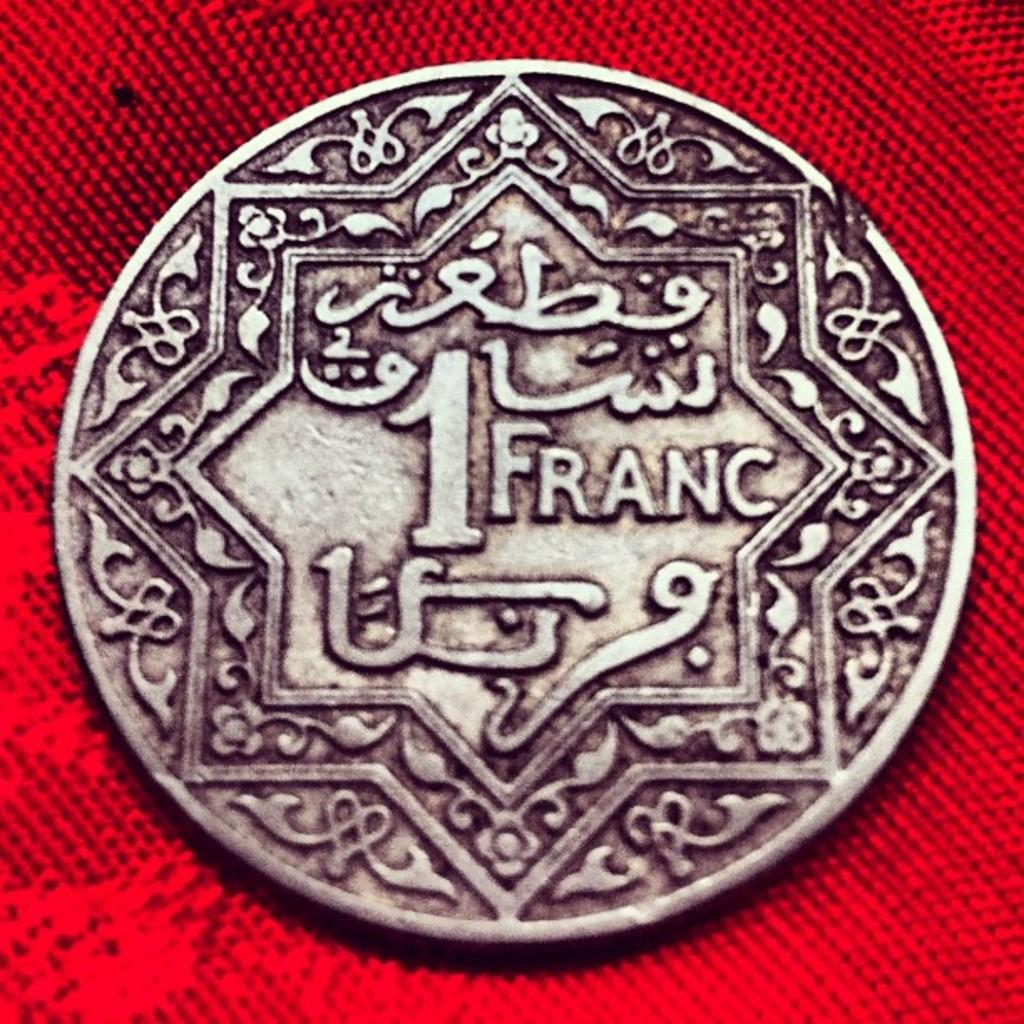Provide a one-sentence caption for the provided image. a close up of a coin with arabic writing for 1 Franc. 